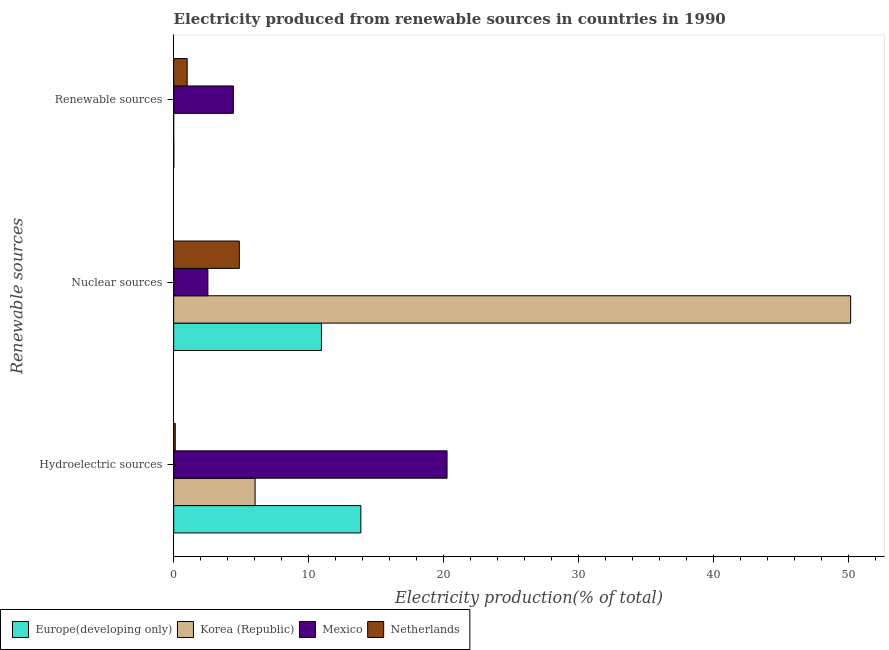Are the number of bars per tick equal to the number of legend labels?
Your response must be concise. Yes. How many bars are there on the 1st tick from the bottom?
Give a very brief answer. 4. What is the label of the 1st group of bars from the top?
Keep it short and to the point. Renewable sources. What is the percentage of electricity produced by renewable sources in Mexico?
Ensure brevity in your answer.  4.43. Across all countries, what is the maximum percentage of electricity produced by nuclear sources?
Make the answer very short. 50.19. Across all countries, what is the minimum percentage of electricity produced by nuclear sources?
Offer a terse response. 2.54. What is the total percentage of electricity produced by renewable sources in the graph?
Provide a short and direct response. 5.44. What is the difference between the percentage of electricity produced by hydroelectric sources in Mexico and that in Netherlands?
Keep it short and to the point. 20.15. What is the difference between the percentage of electricity produced by nuclear sources in Netherlands and the percentage of electricity produced by hydroelectric sources in Europe(developing only)?
Your answer should be very brief. -9.01. What is the average percentage of electricity produced by nuclear sources per country?
Your answer should be compact. 17.14. What is the difference between the percentage of electricity produced by hydroelectric sources and percentage of electricity produced by renewable sources in Netherlands?
Provide a short and direct response. -0.88. What is the ratio of the percentage of electricity produced by renewable sources in Korea (Republic) to that in Mexico?
Make the answer very short. 0. What is the difference between the highest and the second highest percentage of electricity produced by nuclear sources?
Keep it short and to the point. 39.24. What is the difference between the highest and the lowest percentage of electricity produced by nuclear sources?
Make the answer very short. 47.66. Is the sum of the percentage of electricity produced by hydroelectric sources in Netherlands and Korea (Republic) greater than the maximum percentage of electricity produced by nuclear sources across all countries?
Offer a very short reply. No. Are the values on the major ticks of X-axis written in scientific E-notation?
Provide a short and direct response. No. Where does the legend appear in the graph?
Your answer should be compact. Bottom left. How many legend labels are there?
Your answer should be compact. 4. How are the legend labels stacked?
Your answer should be compact. Horizontal. What is the title of the graph?
Ensure brevity in your answer.  Electricity produced from renewable sources in countries in 1990. Does "Estonia" appear as one of the legend labels in the graph?
Your response must be concise. No. What is the label or title of the X-axis?
Ensure brevity in your answer.  Electricity production(% of total). What is the label or title of the Y-axis?
Make the answer very short. Renewable sources. What is the Electricity production(% of total) of Europe(developing only) in Hydroelectric sources?
Provide a short and direct response. 13.88. What is the Electricity production(% of total) in Korea (Republic) in Hydroelectric sources?
Ensure brevity in your answer.  6.04. What is the Electricity production(% of total) in Mexico in Hydroelectric sources?
Provide a short and direct response. 20.27. What is the Electricity production(% of total) of Netherlands in Hydroelectric sources?
Ensure brevity in your answer.  0.12. What is the Electricity production(% of total) of Europe(developing only) in Nuclear sources?
Offer a terse response. 10.96. What is the Electricity production(% of total) in Korea (Republic) in Nuclear sources?
Provide a short and direct response. 50.19. What is the Electricity production(% of total) in Mexico in Nuclear sources?
Your answer should be compact. 2.54. What is the Electricity production(% of total) of Netherlands in Nuclear sources?
Give a very brief answer. 4.87. What is the Electricity production(% of total) of Europe(developing only) in Renewable sources?
Give a very brief answer. 0.01. What is the Electricity production(% of total) of Korea (Republic) in Renewable sources?
Offer a terse response. 0. What is the Electricity production(% of total) of Mexico in Renewable sources?
Make the answer very short. 4.43. What is the Electricity production(% of total) in Netherlands in Renewable sources?
Offer a terse response. 1. Across all Renewable sources, what is the maximum Electricity production(% of total) in Europe(developing only)?
Your answer should be very brief. 13.88. Across all Renewable sources, what is the maximum Electricity production(% of total) of Korea (Republic)?
Make the answer very short. 50.19. Across all Renewable sources, what is the maximum Electricity production(% of total) of Mexico?
Your answer should be compact. 20.27. Across all Renewable sources, what is the maximum Electricity production(% of total) in Netherlands?
Your response must be concise. 4.87. Across all Renewable sources, what is the minimum Electricity production(% of total) of Europe(developing only)?
Make the answer very short. 0.01. Across all Renewable sources, what is the minimum Electricity production(% of total) in Korea (Republic)?
Your answer should be compact. 0. Across all Renewable sources, what is the minimum Electricity production(% of total) of Mexico?
Make the answer very short. 2.54. Across all Renewable sources, what is the minimum Electricity production(% of total) in Netherlands?
Your response must be concise. 0.12. What is the total Electricity production(% of total) of Europe(developing only) in the graph?
Give a very brief answer. 24.84. What is the total Electricity production(% of total) of Korea (Republic) in the graph?
Offer a terse response. 56.23. What is the total Electricity production(% of total) in Mexico in the graph?
Make the answer very short. 27.23. What is the total Electricity production(% of total) in Netherlands in the graph?
Give a very brief answer. 5.99. What is the difference between the Electricity production(% of total) of Europe(developing only) in Hydroelectric sources and that in Nuclear sources?
Give a very brief answer. 2.92. What is the difference between the Electricity production(% of total) of Korea (Republic) in Hydroelectric sources and that in Nuclear sources?
Your answer should be compact. -44.15. What is the difference between the Electricity production(% of total) in Mexico in Hydroelectric sources and that in Nuclear sources?
Ensure brevity in your answer.  17.73. What is the difference between the Electricity production(% of total) in Netherlands in Hydroelectric sources and that in Nuclear sources?
Give a very brief answer. -4.75. What is the difference between the Electricity production(% of total) of Europe(developing only) in Hydroelectric sources and that in Renewable sources?
Provide a short and direct response. 13.87. What is the difference between the Electricity production(% of total) of Korea (Republic) in Hydroelectric sources and that in Renewable sources?
Provide a succinct answer. 6.04. What is the difference between the Electricity production(% of total) of Mexico in Hydroelectric sources and that in Renewable sources?
Provide a succinct answer. 15.84. What is the difference between the Electricity production(% of total) in Netherlands in Hydroelectric sources and that in Renewable sources?
Your response must be concise. -0.88. What is the difference between the Electricity production(% of total) in Europe(developing only) in Nuclear sources and that in Renewable sources?
Your answer should be compact. 10.95. What is the difference between the Electricity production(% of total) in Korea (Republic) in Nuclear sources and that in Renewable sources?
Offer a terse response. 50.19. What is the difference between the Electricity production(% of total) of Mexico in Nuclear sources and that in Renewable sources?
Ensure brevity in your answer.  -1.89. What is the difference between the Electricity production(% of total) of Netherlands in Nuclear sources and that in Renewable sources?
Provide a succinct answer. 3.87. What is the difference between the Electricity production(% of total) of Europe(developing only) in Hydroelectric sources and the Electricity production(% of total) of Korea (Republic) in Nuclear sources?
Make the answer very short. -36.31. What is the difference between the Electricity production(% of total) in Europe(developing only) in Hydroelectric sources and the Electricity production(% of total) in Mexico in Nuclear sources?
Make the answer very short. 11.34. What is the difference between the Electricity production(% of total) of Europe(developing only) in Hydroelectric sources and the Electricity production(% of total) of Netherlands in Nuclear sources?
Give a very brief answer. 9.01. What is the difference between the Electricity production(% of total) of Korea (Republic) in Hydroelectric sources and the Electricity production(% of total) of Mexico in Nuclear sources?
Your answer should be compact. 3.5. What is the difference between the Electricity production(% of total) in Korea (Republic) in Hydroelectric sources and the Electricity production(% of total) in Netherlands in Nuclear sources?
Your answer should be very brief. 1.17. What is the difference between the Electricity production(% of total) of Mexico in Hydroelectric sources and the Electricity production(% of total) of Netherlands in Nuclear sources?
Your answer should be very brief. 15.4. What is the difference between the Electricity production(% of total) of Europe(developing only) in Hydroelectric sources and the Electricity production(% of total) of Korea (Republic) in Renewable sources?
Provide a succinct answer. 13.88. What is the difference between the Electricity production(% of total) of Europe(developing only) in Hydroelectric sources and the Electricity production(% of total) of Mexico in Renewable sources?
Make the answer very short. 9.45. What is the difference between the Electricity production(% of total) in Europe(developing only) in Hydroelectric sources and the Electricity production(% of total) in Netherlands in Renewable sources?
Your answer should be very brief. 12.88. What is the difference between the Electricity production(% of total) of Korea (Republic) in Hydroelectric sources and the Electricity production(% of total) of Mexico in Renewable sources?
Your answer should be compact. 1.61. What is the difference between the Electricity production(% of total) of Korea (Republic) in Hydroelectric sources and the Electricity production(% of total) of Netherlands in Renewable sources?
Give a very brief answer. 5.04. What is the difference between the Electricity production(% of total) of Mexico in Hydroelectric sources and the Electricity production(% of total) of Netherlands in Renewable sources?
Offer a very short reply. 19.27. What is the difference between the Electricity production(% of total) in Europe(developing only) in Nuclear sources and the Electricity production(% of total) in Korea (Republic) in Renewable sources?
Provide a short and direct response. 10.95. What is the difference between the Electricity production(% of total) of Europe(developing only) in Nuclear sources and the Electricity production(% of total) of Mexico in Renewable sources?
Make the answer very short. 6.53. What is the difference between the Electricity production(% of total) of Europe(developing only) in Nuclear sources and the Electricity production(% of total) of Netherlands in Renewable sources?
Offer a very short reply. 9.95. What is the difference between the Electricity production(% of total) in Korea (Republic) in Nuclear sources and the Electricity production(% of total) in Mexico in Renewable sources?
Your response must be concise. 45.77. What is the difference between the Electricity production(% of total) in Korea (Republic) in Nuclear sources and the Electricity production(% of total) in Netherlands in Renewable sources?
Provide a short and direct response. 49.19. What is the difference between the Electricity production(% of total) in Mexico in Nuclear sources and the Electricity production(% of total) in Netherlands in Renewable sources?
Keep it short and to the point. 1.53. What is the average Electricity production(% of total) in Europe(developing only) per Renewable sources?
Your response must be concise. 8.28. What is the average Electricity production(% of total) in Korea (Republic) per Renewable sources?
Ensure brevity in your answer.  18.74. What is the average Electricity production(% of total) of Mexico per Renewable sources?
Your answer should be compact. 9.08. What is the average Electricity production(% of total) of Netherlands per Renewable sources?
Keep it short and to the point. 2. What is the difference between the Electricity production(% of total) of Europe(developing only) and Electricity production(% of total) of Korea (Republic) in Hydroelectric sources?
Your answer should be compact. 7.84. What is the difference between the Electricity production(% of total) of Europe(developing only) and Electricity production(% of total) of Mexico in Hydroelectric sources?
Offer a terse response. -6.39. What is the difference between the Electricity production(% of total) in Europe(developing only) and Electricity production(% of total) in Netherlands in Hydroelectric sources?
Provide a succinct answer. 13.76. What is the difference between the Electricity production(% of total) in Korea (Republic) and Electricity production(% of total) in Mexico in Hydroelectric sources?
Your response must be concise. -14.23. What is the difference between the Electricity production(% of total) in Korea (Republic) and Electricity production(% of total) in Netherlands in Hydroelectric sources?
Provide a succinct answer. 5.92. What is the difference between the Electricity production(% of total) of Mexico and Electricity production(% of total) of Netherlands in Hydroelectric sources?
Ensure brevity in your answer.  20.15. What is the difference between the Electricity production(% of total) of Europe(developing only) and Electricity production(% of total) of Korea (Republic) in Nuclear sources?
Keep it short and to the point. -39.24. What is the difference between the Electricity production(% of total) of Europe(developing only) and Electricity production(% of total) of Mexico in Nuclear sources?
Give a very brief answer. 8.42. What is the difference between the Electricity production(% of total) of Europe(developing only) and Electricity production(% of total) of Netherlands in Nuclear sources?
Ensure brevity in your answer.  6.09. What is the difference between the Electricity production(% of total) in Korea (Republic) and Electricity production(% of total) in Mexico in Nuclear sources?
Offer a very short reply. 47.66. What is the difference between the Electricity production(% of total) of Korea (Republic) and Electricity production(% of total) of Netherlands in Nuclear sources?
Offer a terse response. 45.32. What is the difference between the Electricity production(% of total) in Mexico and Electricity production(% of total) in Netherlands in Nuclear sources?
Provide a short and direct response. -2.33. What is the difference between the Electricity production(% of total) of Europe(developing only) and Electricity production(% of total) of Korea (Republic) in Renewable sources?
Provide a succinct answer. 0.01. What is the difference between the Electricity production(% of total) of Europe(developing only) and Electricity production(% of total) of Mexico in Renewable sources?
Provide a short and direct response. -4.42. What is the difference between the Electricity production(% of total) of Europe(developing only) and Electricity production(% of total) of Netherlands in Renewable sources?
Offer a terse response. -0.99. What is the difference between the Electricity production(% of total) of Korea (Republic) and Electricity production(% of total) of Mexico in Renewable sources?
Keep it short and to the point. -4.42. What is the difference between the Electricity production(% of total) of Korea (Republic) and Electricity production(% of total) of Netherlands in Renewable sources?
Ensure brevity in your answer.  -1. What is the difference between the Electricity production(% of total) in Mexico and Electricity production(% of total) in Netherlands in Renewable sources?
Your answer should be very brief. 3.42. What is the ratio of the Electricity production(% of total) of Europe(developing only) in Hydroelectric sources to that in Nuclear sources?
Provide a short and direct response. 1.27. What is the ratio of the Electricity production(% of total) in Korea (Republic) in Hydroelectric sources to that in Nuclear sources?
Ensure brevity in your answer.  0.12. What is the ratio of the Electricity production(% of total) in Mexico in Hydroelectric sources to that in Nuclear sources?
Keep it short and to the point. 7.99. What is the ratio of the Electricity production(% of total) in Netherlands in Hydroelectric sources to that in Nuclear sources?
Provide a succinct answer. 0.02. What is the ratio of the Electricity production(% of total) of Europe(developing only) in Hydroelectric sources to that in Renewable sources?
Your response must be concise. 1438.58. What is the ratio of the Electricity production(% of total) in Korea (Republic) in Hydroelectric sources to that in Renewable sources?
Your answer should be compact. 6361. What is the ratio of the Electricity production(% of total) of Mexico in Hydroelectric sources to that in Renewable sources?
Ensure brevity in your answer.  4.58. What is the ratio of the Electricity production(% of total) in Netherlands in Hydroelectric sources to that in Renewable sources?
Give a very brief answer. 0.12. What is the ratio of the Electricity production(% of total) of Europe(developing only) in Nuclear sources to that in Renewable sources?
Your answer should be compact. 1135.55. What is the ratio of the Electricity production(% of total) of Korea (Republic) in Nuclear sources to that in Renewable sources?
Provide a succinct answer. 5.29e+04. What is the ratio of the Electricity production(% of total) in Mexico in Nuclear sources to that in Renewable sources?
Offer a very short reply. 0.57. What is the ratio of the Electricity production(% of total) in Netherlands in Nuclear sources to that in Renewable sources?
Provide a succinct answer. 4.86. What is the difference between the highest and the second highest Electricity production(% of total) of Europe(developing only)?
Provide a succinct answer. 2.92. What is the difference between the highest and the second highest Electricity production(% of total) in Korea (Republic)?
Offer a terse response. 44.15. What is the difference between the highest and the second highest Electricity production(% of total) in Mexico?
Provide a succinct answer. 15.84. What is the difference between the highest and the second highest Electricity production(% of total) in Netherlands?
Offer a very short reply. 3.87. What is the difference between the highest and the lowest Electricity production(% of total) of Europe(developing only)?
Offer a very short reply. 13.87. What is the difference between the highest and the lowest Electricity production(% of total) of Korea (Republic)?
Ensure brevity in your answer.  50.19. What is the difference between the highest and the lowest Electricity production(% of total) of Mexico?
Your response must be concise. 17.73. What is the difference between the highest and the lowest Electricity production(% of total) of Netherlands?
Offer a terse response. 4.75. 